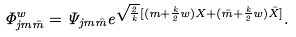Convert formula to latex. <formula><loc_0><loc_0><loc_500><loc_500>\Phi _ { j m \bar { m } } ^ { w } = \Psi _ { j m \bar { m } } e ^ { \sqrt { \frac { 2 } { k } } [ ( m + \frac { k } { 2 } w ) X + ( \bar { m } + \frac { k } { 2 } w ) \bar { X } ] } .</formula> 